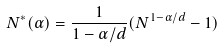Convert formula to latex. <formula><loc_0><loc_0><loc_500><loc_500>N ^ { * } ( \alpha ) = \frac { 1 } { 1 - \alpha / d } ( N ^ { 1 - \alpha / d } - 1 )</formula> 